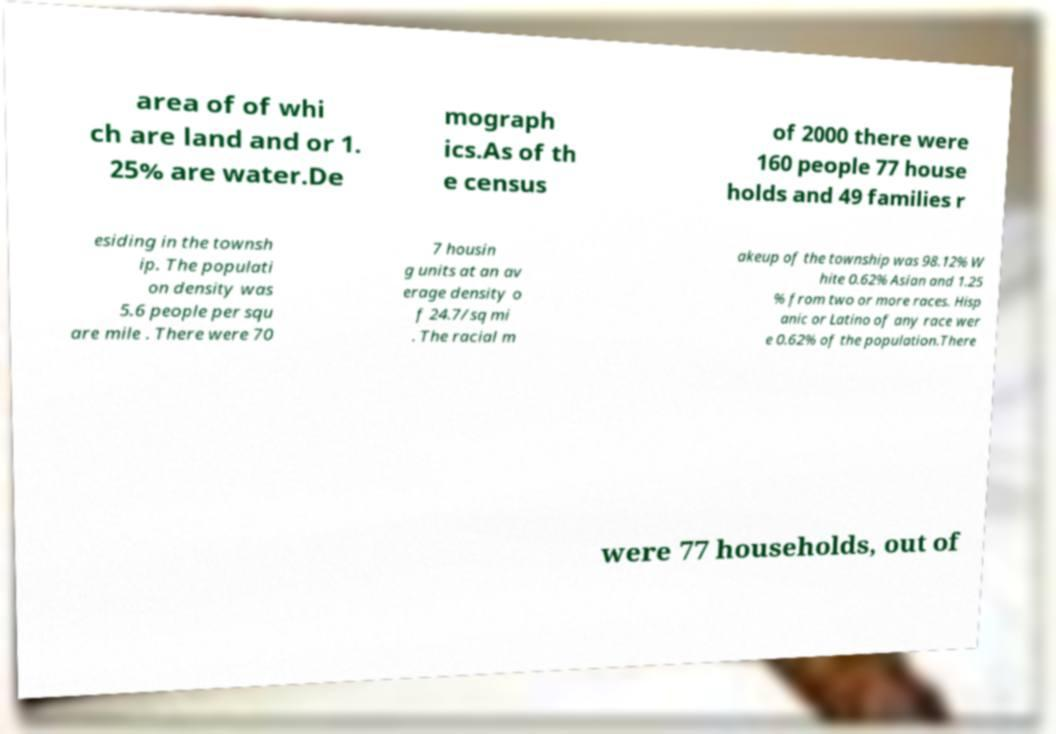There's text embedded in this image that I need extracted. Can you transcribe it verbatim? area of of whi ch are land and or 1. 25% are water.De mograph ics.As of th e census of 2000 there were 160 people 77 house holds and 49 families r esiding in the townsh ip. The populati on density was 5.6 people per squ are mile . There were 70 7 housin g units at an av erage density o f 24.7/sq mi . The racial m akeup of the township was 98.12% W hite 0.62% Asian and 1.25 % from two or more races. Hisp anic or Latino of any race wer e 0.62% of the population.There were 77 households, out of 